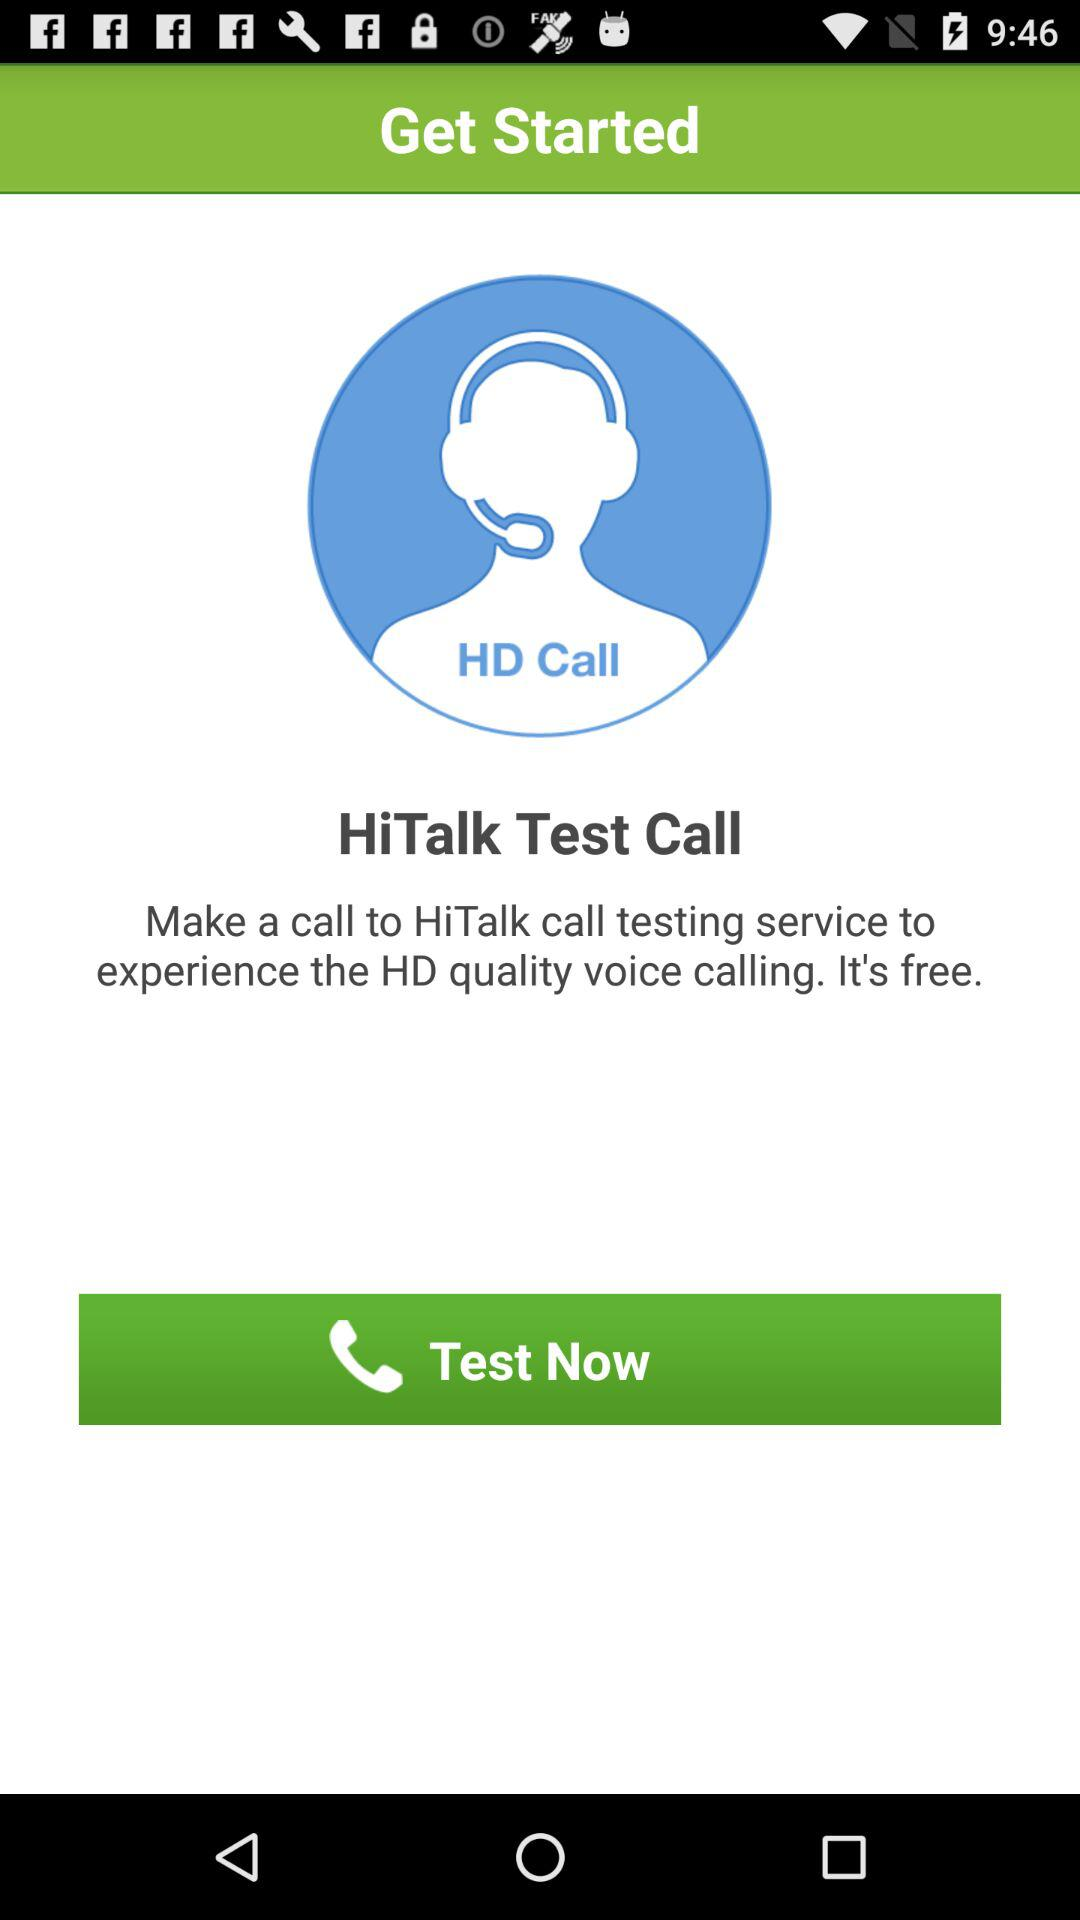What is the name of the application? The application name is "HiTalk Test Call". 